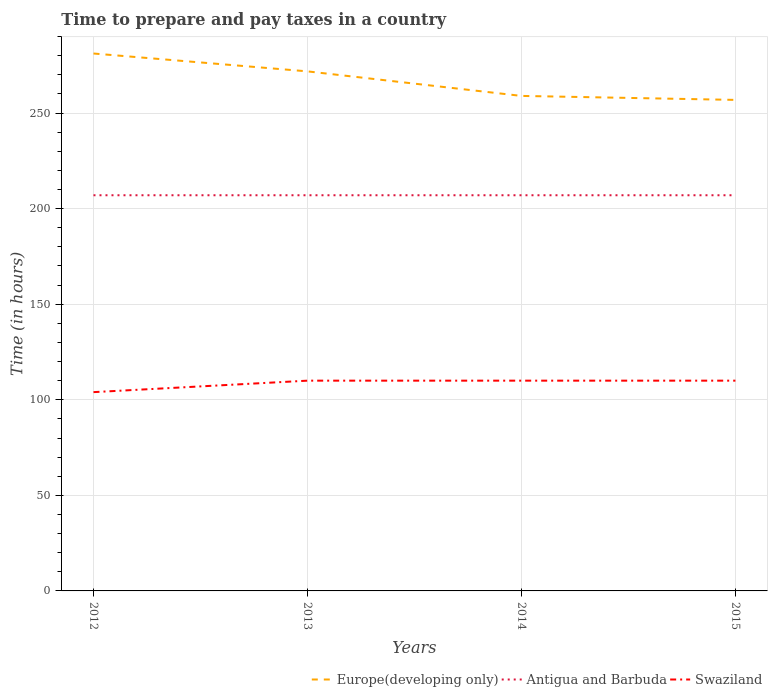Does the line corresponding to Swaziland intersect with the line corresponding to Antigua and Barbuda?
Make the answer very short. No. Across all years, what is the maximum number of hours required to prepare and pay taxes in Swaziland?
Your answer should be compact. 104. What is the total number of hours required to prepare and pay taxes in Swaziland in the graph?
Make the answer very short. -6. What is the difference between the highest and the second highest number of hours required to prepare and pay taxes in Antigua and Barbuda?
Ensure brevity in your answer.  0. What is the difference between the highest and the lowest number of hours required to prepare and pay taxes in Europe(developing only)?
Give a very brief answer. 2. Is the number of hours required to prepare and pay taxes in Europe(developing only) strictly greater than the number of hours required to prepare and pay taxes in Antigua and Barbuda over the years?
Offer a terse response. No. How many lines are there?
Your answer should be very brief. 3. How many years are there in the graph?
Provide a short and direct response. 4. Are the values on the major ticks of Y-axis written in scientific E-notation?
Offer a terse response. No. Does the graph contain any zero values?
Provide a succinct answer. No. Where does the legend appear in the graph?
Ensure brevity in your answer.  Bottom right. How are the legend labels stacked?
Your answer should be compact. Horizontal. What is the title of the graph?
Your answer should be compact. Time to prepare and pay taxes in a country. What is the label or title of the X-axis?
Offer a very short reply. Years. What is the label or title of the Y-axis?
Your answer should be compact. Time (in hours). What is the Time (in hours) of Europe(developing only) in 2012?
Your answer should be very brief. 281.16. What is the Time (in hours) of Antigua and Barbuda in 2012?
Offer a terse response. 207. What is the Time (in hours) in Swaziland in 2012?
Provide a succinct answer. 104. What is the Time (in hours) of Europe(developing only) in 2013?
Ensure brevity in your answer.  271.82. What is the Time (in hours) of Antigua and Barbuda in 2013?
Your response must be concise. 207. What is the Time (in hours) of Swaziland in 2013?
Provide a short and direct response. 110. What is the Time (in hours) of Europe(developing only) in 2014?
Your answer should be compact. 258.97. What is the Time (in hours) of Antigua and Barbuda in 2014?
Make the answer very short. 207. What is the Time (in hours) of Swaziland in 2014?
Ensure brevity in your answer.  110. What is the Time (in hours) of Europe(developing only) in 2015?
Keep it short and to the point. 256.88. What is the Time (in hours) of Antigua and Barbuda in 2015?
Your response must be concise. 207. What is the Time (in hours) of Swaziland in 2015?
Make the answer very short. 110. Across all years, what is the maximum Time (in hours) of Europe(developing only)?
Your answer should be compact. 281.16. Across all years, what is the maximum Time (in hours) in Antigua and Barbuda?
Provide a succinct answer. 207. Across all years, what is the maximum Time (in hours) in Swaziland?
Make the answer very short. 110. Across all years, what is the minimum Time (in hours) in Europe(developing only)?
Offer a very short reply. 256.88. Across all years, what is the minimum Time (in hours) of Antigua and Barbuda?
Make the answer very short. 207. Across all years, what is the minimum Time (in hours) in Swaziland?
Your response must be concise. 104. What is the total Time (in hours) of Europe(developing only) in the graph?
Your response must be concise. 1068.83. What is the total Time (in hours) of Antigua and Barbuda in the graph?
Offer a terse response. 828. What is the total Time (in hours) of Swaziland in the graph?
Provide a succinct answer. 434. What is the difference between the Time (in hours) in Europe(developing only) in 2012 and that in 2013?
Keep it short and to the point. 9.34. What is the difference between the Time (in hours) in Antigua and Barbuda in 2012 and that in 2013?
Make the answer very short. 0. What is the difference between the Time (in hours) in Swaziland in 2012 and that in 2013?
Your response must be concise. -6. What is the difference between the Time (in hours) of Europe(developing only) in 2012 and that in 2014?
Offer a very short reply. 22.18. What is the difference between the Time (in hours) of Antigua and Barbuda in 2012 and that in 2014?
Your answer should be very brief. 0. What is the difference between the Time (in hours) in Europe(developing only) in 2012 and that in 2015?
Offer a terse response. 24.27. What is the difference between the Time (in hours) in Antigua and Barbuda in 2012 and that in 2015?
Your response must be concise. 0. What is the difference between the Time (in hours) in Swaziland in 2012 and that in 2015?
Provide a succinct answer. -6. What is the difference between the Time (in hours) of Europe(developing only) in 2013 and that in 2014?
Your answer should be compact. 12.84. What is the difference between the Time (in hours) of Swaziland in 2013 and that in 2014?
Keep it short and to the point. 0. What is the difference between the Time (in hours) in Europe(developing only) in 2013 and that in 2015?
Provide a short and direct response. 14.93. What is the difference between the Time (in hours) in Europe(developing only) in 2014 and that in 2015?
Your answer should be compact. 2.09. What is the difference between the Time (in hours) of Antigua and Barbuda in 2014 and that in 2015?
Your response must be concise. 0. What is the difference between the Time (in hours) of Europe(developing only) in 2012 and the Time (in hours) of Antigua and Barbuda in 2013?
Your answer should be compact. 74.16. What is the difference between the Time (in hours) of Europe(developing only) in 2012 and the Time (in hours) of Swaziland in 2013?
Offer a very short reply. 171.16. What is the difference between the Time (in hours) in Antigua and Barbuda in 2012 and the Time (in hours) in Swaziland in 2013?
Ensure brevity in your answer.  97. What is the difference between the Time (in hours) of Europe(developing only) in 2012 and the Time (in hours) of Antigua and Barbuda in 2014?
Your answer should be compact. 74.16. What is the difference between the Time (in hours) in Europe(developing only) in 2012 and the Time (in hours) in Swaziland in 2014?
Offer a terse response. 171.16. What is the difference between the Time (in hours) in Antigua and Barbuda in 2012 and the Time (in hours) in Swaziland in 2014?
Ensure brevity in your answer.  97. What is the difference between the Time (in hours) in Europe(developing only) in 2012 and the Time (in hours) in Antigua and Barbuda in 2015?
Ensure brevity in your answer.  74.16. What is the difference between the Time (in hours) of Europe(developing only) in 2012 and the Time (in hours) of Swaziland in 2015?
Provide a succinct answer. 171.16. What is the difference between the Time (in hours) in Antigua and Barbuda in 2012 and the Time (in hours) in Swaziland in 2015?
Ensure brevity in your answer.  97. What is the difference between the Time (in hours) of Europe(developing only) in 2013 and the Time (in hours) of Antigua and Barbuda in 2014?
Offer a terse response. 64.82. What is the difference between the Time (in hours) in Europe(developing only) in 2013 and the Time (in hours) in Swaziland in 2014?
Keep it short and to the point. 161.82. What is the difference between the Time (in hours) in Antigua and Barbuda in 2013 and the Time (in hours) in Swaziland in 2014?
Offer a terse response. 97. What is the difference between the Time (in hours) of Europe(developing only) in 2013 and the Time (in hours) of Antigua and Barbuda in 2015?
Keep it short and to the point. 64.82. What is the difference between the Time (in hours) in Europe(developing only) in 2013 and the Time (in hours) in Swaziland in 2015?
Provide a short and direct response. 161.82. What is the difference between the Time (in hours) in Antigua and Barbuda in 2013 and the Time (in hours) in Swaziland in 2015?
Your answer should be very brief. 97. What is the difference between the Time (in hours) in Europe(developing only) in 2014 and the Time (in hours) in Antigua and Barbuda in 2015?
Offer a very short reply. 51.97. What is the difference between the Time (in hours) of Europe(developing only) in 2014 and the Time (in hours) of Swaziland in 2015?
Your answer should be very brief. 148.97. What is the difference between the Time (in hours) in Antigua and Barbuda in 2014 and the Time (in hours) in Swaziland in 2015?
Your response must be concise. 97. What is the average Time (in hours) of Europe(developing only) per year?
Make the answer very short. 267.21. What is the average Time (in hours) of Antigua and Barbuda per year?
Keep it short and to the point. 207. What is the average Time (in hours) of Swaziland per year?
Your response must be concise. 108.5. In the year 2012, what is the difference between the Time (in hours) of Europe(developing only) and Time (in hours) of Antigua and Barbuda?
Provide a short and direct response. 74.16. In the year 2012, what is the difference between the Time (in hours) in Europe(developing only) and Time (in hours) in Swaziland?
Your answer should be compact. 177.16. In the year 2012, what is the difference between the Time (in hours) in Antigua and Barbuda and Time (in hours) in Swaziland?
Your answer should be very brief. 103. In the year 2013, what is the difference between the Time (in hours) of Europe(developing only) and Time (in hours) of Antigua and Barbuda?
Your answer should be very brief. 64.82. In the year 2013, what is the difference between the Time (in hours) in Europe(developing only) and Time (in hours) in Swaziland?
Your answer should be compact. 161.82. In the year 2013, what is the difference between the Time (in hours) of Antigua and Barbuda and Time (in hours) of Swaziland?
Provide a short and direct response. 97. In the year 2014, what is the difference between the Time (in hours) of Europe(developing only) and Time (in hours) of Antigua and Barbuda?
Provide a short and direct response. 51.97. In the year 2014, what is the difference between the Time (in hours) in Europe(developing only) and Time (in hours) in Swaziland?
Make the answer very short. 148.97. In the year 2014, what is the difference between the Time (in hours) in Antigua and Barbuda and Time (in hours) in Swaziland?
Your answer should be compact. 97. In the year 2015, what is the difference between the Time (in hours) in Europe(developing only) and Time (in hours) in Antigua and Barbuda?
Offer a terse response. 49.88. In the year 2015, what is the difference between the Time (in hours) in Europe(developing only) and Time (in hours) in Swaziland?
Your answer should be compact. 146.88. In the year 2015, what is the difference between the Time (in hours) in Antigua and Barbuda and Time (in hours) in Swaziland?
Make the answer very short. 97. What is the ratio of the Time (in hours) of Europe(developing only) in 2012 to that in 2013?
Your response must be concise. 1.03. What is the ratio of the Time (in hours) of Antigua and Barbuda in 2012 to that in 2013?
Your answer should be compact. 1. What is the ratio of the Time (in hours) in Swaziland in 2012 to that in 2013?
Offer a terse response. 0.95. What is the ratio of the Time (in hours) of Europe(developing only) in 2012 to that in 2014?
Provide a succinct answer. 1.09. What is the ratio of the Time (in hours) in Antigua and Barbuda in 2012 to that in 2014?
Give a very brief answer. 1. What is the ratio of the Time (in hours) of Swaziland in 2012 to that in 2014?
Keep it short and to the point. 0.95. What is the ratio of the Time (in hours) of Europe(developing only) in 2012 to that in 2015?
Offer a terse response. 1.09. What is the ratio of the Time (in hours) of Swaziland in 2012 to that in 2015?
Make the answer very short. 0.95. What is the ratio of the Time (in hours) in Europe(developing only) in 2013 to that in 2014?
Give a very brief answer. 1.05. What is the ratio of the Time (in hours) of Swaziland in 2013 to that in 2014?
Offer a very short reply. 1. What is the ratio of the Time (in hours) in Europe(developing only) in 2013 to that in 2015?
Offer a very short reply. 1.06. What is the ratio of the Time (in hours) of Swaziland in 2013 to that in 2015?
Your response must be concise. 1. What is the difference between the highest and the second highest Time (in hours) in Europe(developing only)?
Keep it short and to the point. 9.34. What is the difference between the highest and the lowest Time (in hours) of Europe(developing only)?
Offer a very short reply. 24.27. What is the difference between the highest and the lowest Time (in hours) in Swaziland?
Provide a succinct answer. 6. 